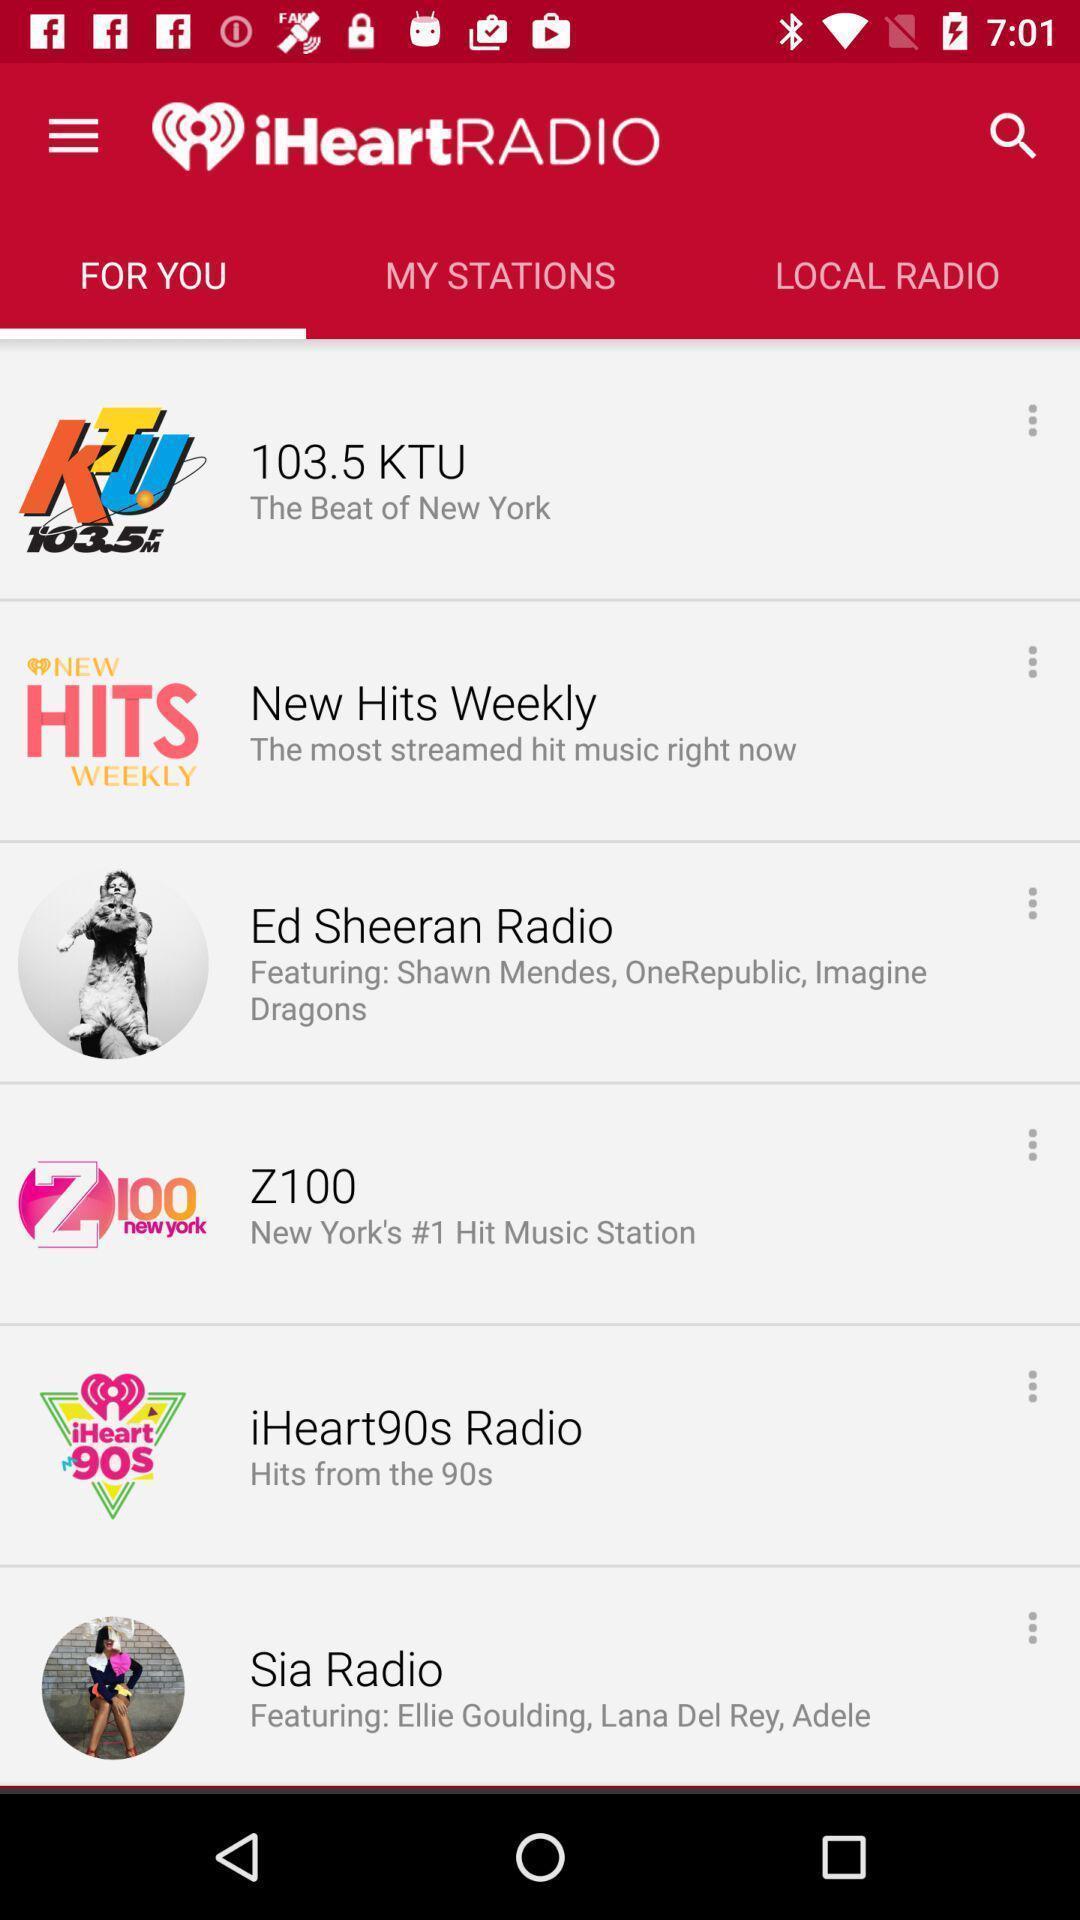What can you discern from this picture? Page showing the various options in for you tab. 